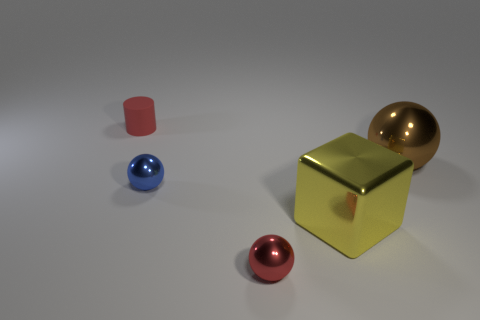How many big things are either yellow metal blocks or matte things?
Ensure brevity in your answer.  1. There is a big thing that is in front of the small shiny ball that is behind the small ball in front of the large yellow block; what color is it?
Your answer should be compact. Yellow. How many other objects are the same color as the tiny rubber object?
Make the answer very short. 1. What number of rubber things are either small red cylinders or blue things?
Your response must be concise. 1. There is a small thing that is behind the brown metal thing; is it the same color as the metal sphere in front of the big metallic block?
Offer a terse response. Yes. Are there any other things that have the same material as the red cylinder?
Ensure brevity in your answer.  No. What size is the brown metallic object that is the same shape as the red shiny thing?
Your answer should be very brief. Large. Are there more tiny blue metal objects in front of the tiny red rubber object than rubber balls?
Give a very brief answer. Yes. Is the red thing in front of the large sphere made of the same material as the yellow cube?
Make the answer very short. Yes. There is a metal sphere right of the tiny red object in front of the tiny red thing that is behind the big yellow thing; how big is it?
Offer a very short reply. Large. 